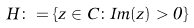<formula> <loc_0><loc_0><loc_500><loc_500>H \colon = \{ z \in C \colon I m ( z ) > 0 \}</formula> 